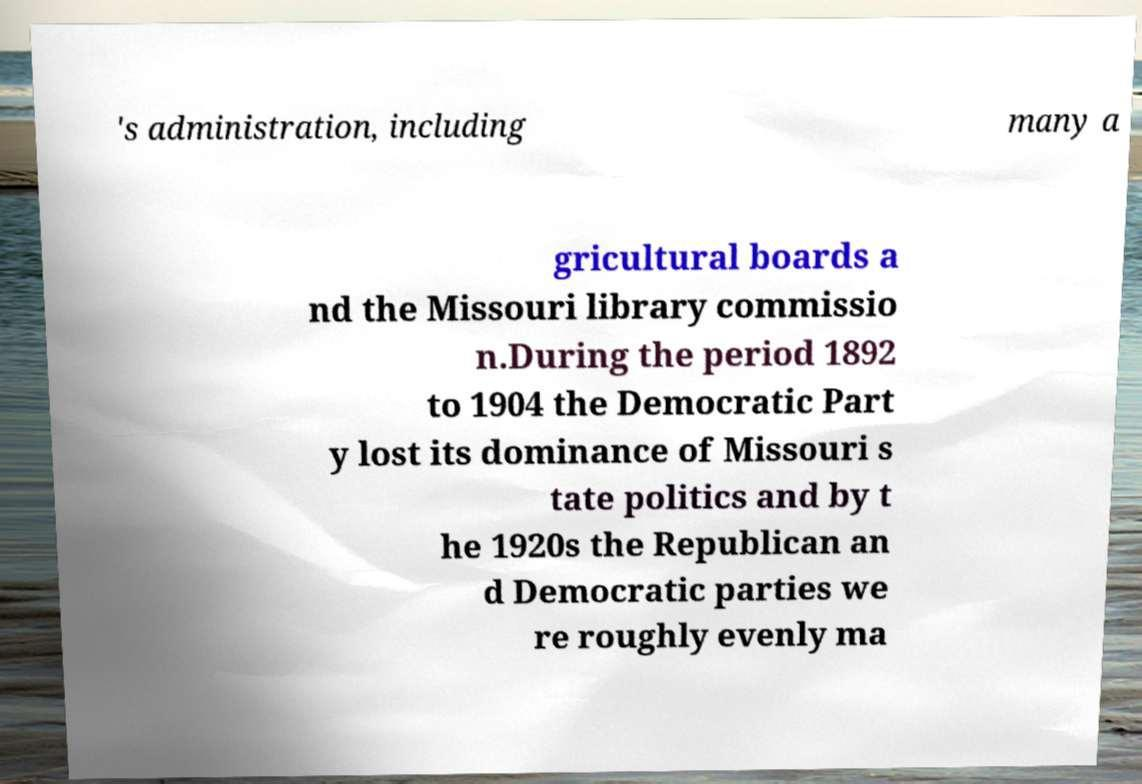There's text embedded in this image that I need extracted. Can you transcribe it verbatim? 's administration, including many a gricultural boards a nd the Missouri library commissio n.During the period 1892 to 1904 the Democratic Part y lost its dominance of Missouri s tate politics and by t he 1920s the Republican an d Democratic parties we re roughly evenly ma 